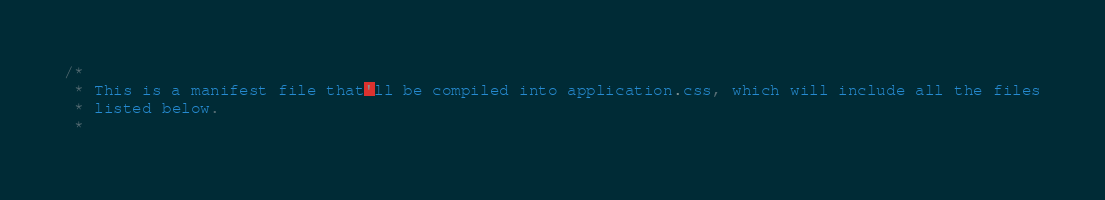<code> <loc_0><loc_0><loc_500><loc_500><_CSS_>/*
 * This is a manifest file that'll be compiled into application.css, which will include all the files
 * listed below.
 *</code> 